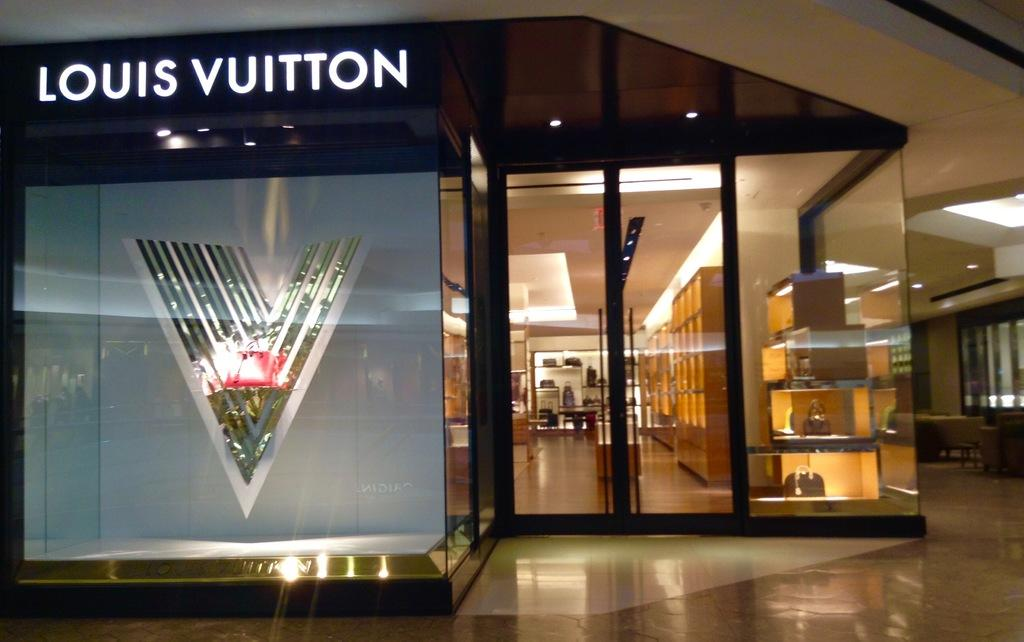<image>
Create a compact narrative representing the image presented. Retail storefront that says Louis Vuitton in front. 